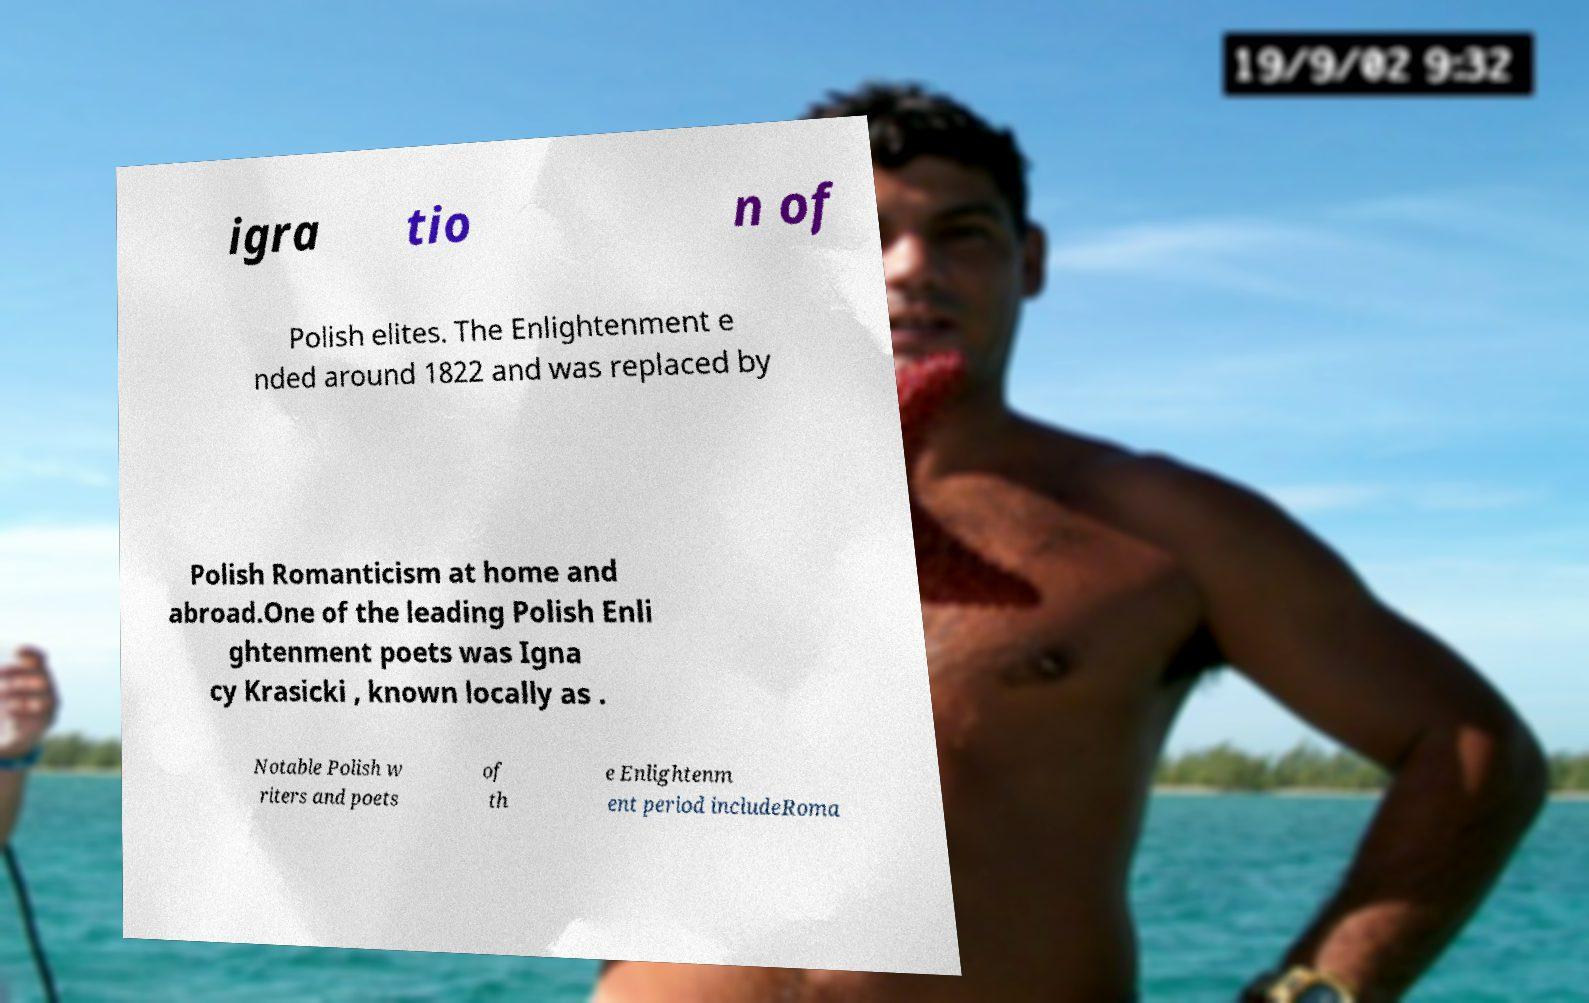For documentation purposes, I need the text within this image transcribed. Could you provide that? igra tio n of Polish elites. The Enlightenment e nded around 1822 and was replaced by Polish Romanticism at home and abroad.One of the leading Polish Enli ghtenment poets was Igna cy Krasicki , known locally as . Notable Polish w riters and poets of th e Enlightenm ent period includeRoma 